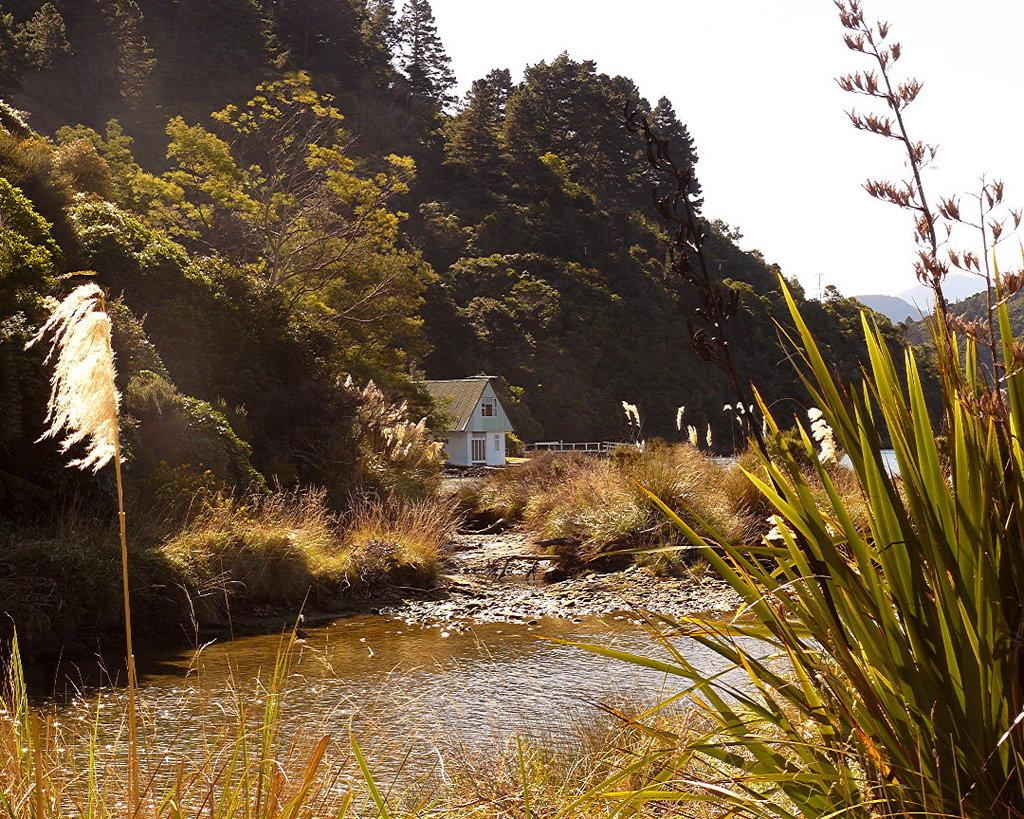What is the primary element visible in the image? There is water in the image. What type of vegetation can be seen in the image? There is grass in the image. What can be seen in the background of the image? There are trees and a house in the background of the image. What part of the natural environment is visible in the image? The sky is visible in the background of the image. What type of apparel is the water wearing in the image? The water does not wear apparel, as it is a natural element and not a living being. 